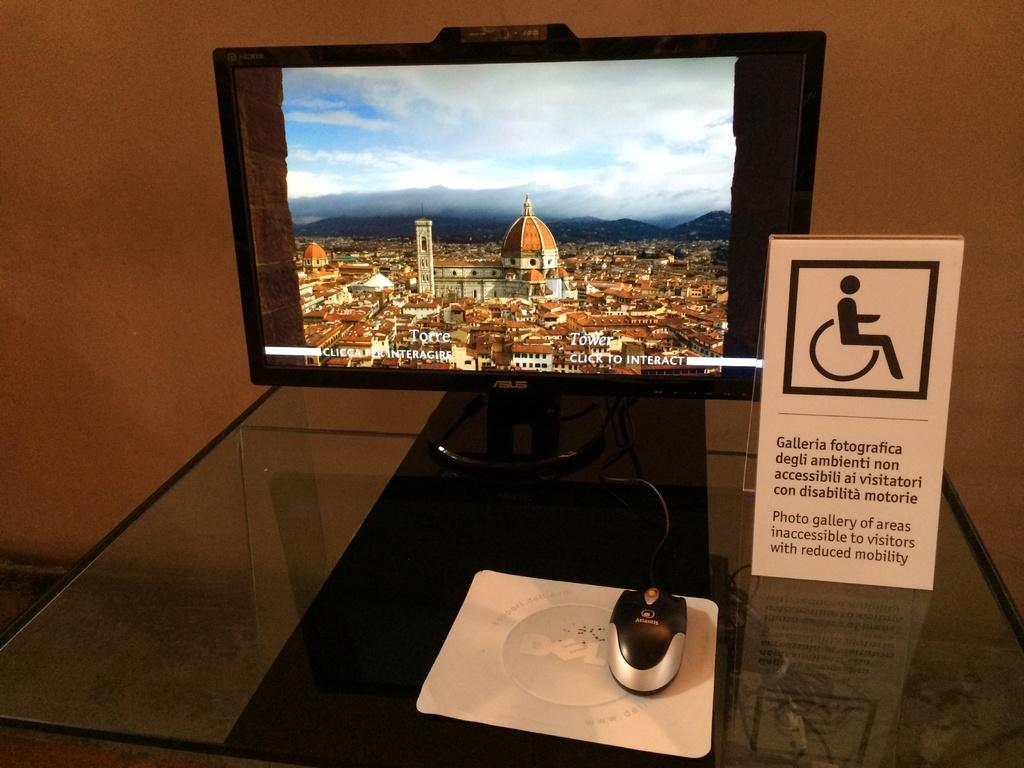<image>
Offer a succinct explanation of the picture presented. the word galleria that is next to a screen 